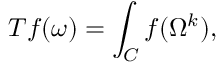Convert formula to latex. <formula><loc_0><loc_0><loc_500><loc_500>T f ( \omega ) = \int _ { C } f ( \Omega ^ { k } ) ,</formula> 